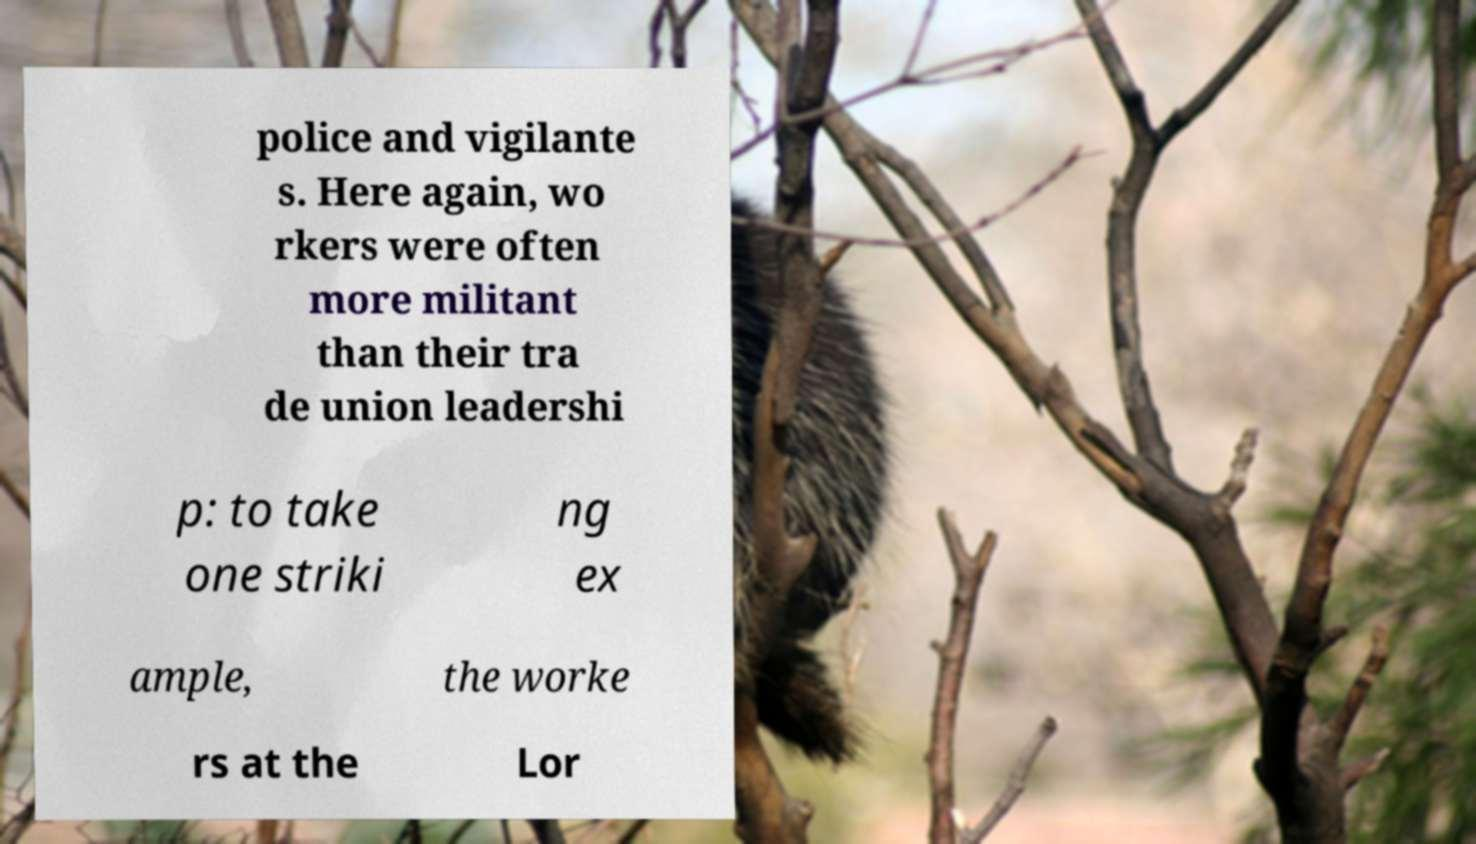What messages or text are displayed in this image? I need them in a readable, typed format. police and vigilante s. Here again, wo rkers were often more militant than their tra de union leadershi p: to take one striki ng ex ample, the worke rs at the Lor 